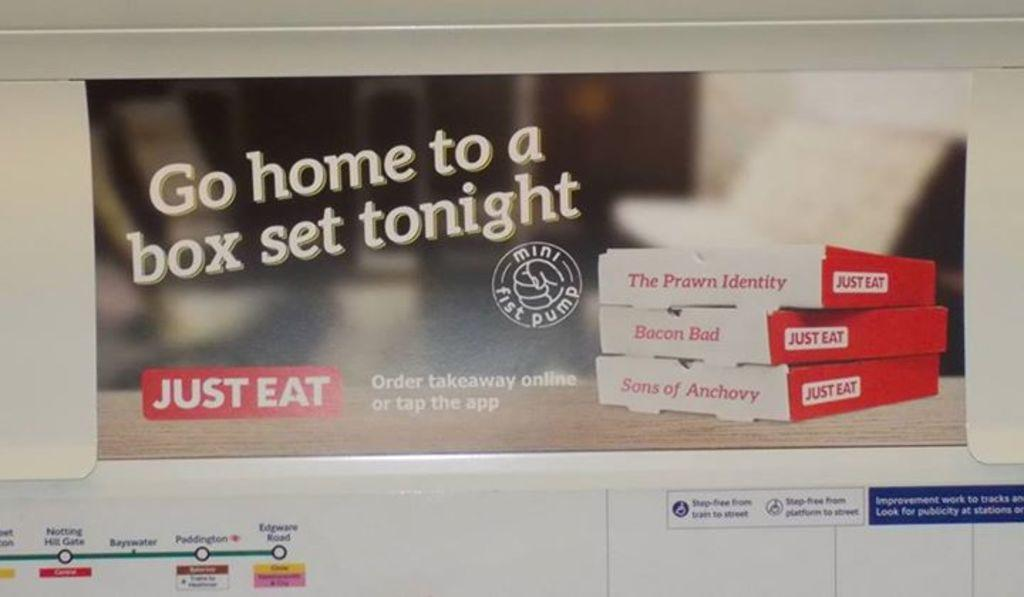<image>
Offer a succinct explanation of the picture presented. a sign that says 'go home to a box set tonight' on it 